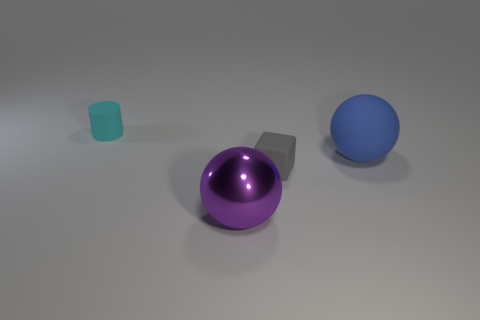There is a sphere that is to the left of the small thing in front of the matte cylinder; is there a big ball that is behind it?
Give a very brief answer. Yes. What number of blocks are large cyan things or small gray objects?
Offer a terse response. 1. There is a small object that is behind the matte thing on the right side of the small gray rubber cube; what is its shape?
Provide a short and direct response. Cylinder. There is a sphere that is left of the rubber thing in front of the big sphere to the right of the purple metallic object; what size is it?
Your answer should be very brief. Large. Does the metallic ball have the same size as the blue ball?
Offer a terse response. Yes. What number of objects are either small cyan matte cylinders or big metallic cylinders?
Your answer should be very brief. 1. How big is the rubber cylinder that is behind the large ball that is in front of the blue thing?
Give a very brief answer. Small. The purple thing has what size?
Offer a very short reply. Large. There is a object that is left of the tiny gray thing and behind the large purple sphere; what shape is it?
Give a very brief answer. Cylinder. There is another big thing that is the same shape as the big rubber thing; what color is it?
Your response must be concise. Purple. 